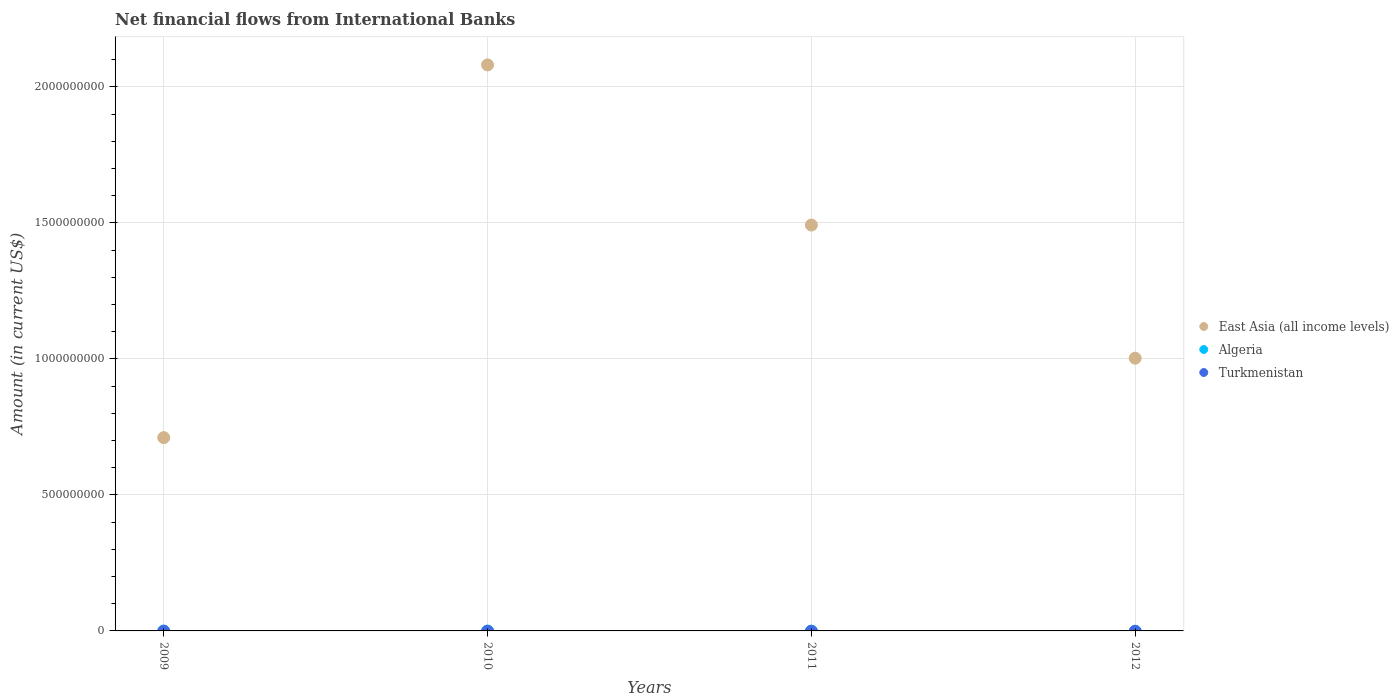What is the net financial aid flows in Turkmenistan in 2012?
Make the answer very short. 0. Across all years, what is the maximum net financial aid flows in East Asia (all income levels)?
Provide a short and direct response. 2.08e+09. Across all years, what is the minimum net financial aid flows in East Asia (all income levels)?
Keep it short and to the point. 7.11e+08. In which year was the net financial aid flows in East Asia (all income levels) maximum?
Provide a short and direct response. 2010. What is the total net financial aid flows in East Asia (all income levels) in the graph?
Your answer should be very brief. 5.29e+09. What is the difference between the net financial aid flows in East Asia (all income levels) in 2009 and that in 2011?
Give a very brief answer. -7.82e+08. What is the difference between the net financial aid flows in East Asia (all income levels) in 2010 and the net financial aid flows in Turkmenistan in 2009?
Provide a succinct answer. 2.08e+09. What is the average net financial aid flows in East Asia (all income levels) per year?
Provide a short and direct response. 1.32e+09. What is the difference between the highest and the second highest net financial aid flows in East Asia (all income levels)?
Your answer should be compact. 5.89e+08. What is the difference between the highest and the lowest net financial aid flows in East Asia (all income levels)?
Provide a succinct answer. 1.37e+09. In how many years, is the net financial aid flows in Algeria greater than the average net financial aid flows in Algeria taken over all years?
Provide a succinct answer. 0. Is the net financial aid flows in Turkmenistan strictly less than the net financial aid flows in East Asia (all income levels) over the years?
Make the answer very short. Yes. How many dotlines are there?
Provide a succinct answer. 1. Does the graph contain any zero values?
Your response must be concise. Yes. What is the title of the graph?
Offer a very short reply. Net financial flows from International Banks. Does "Cambodia" appear as one of the legend labels in the graph?
Your answer should be very brief. No. What is the label or title of the X-axis?
Give a very brief answer. Years. What is the label or title of the Y-axis?
Offer a terse response. Amount (in current US$). What is the Amount (in current US$) of East Asia (all income levels) in 2009?
Keep it short and to the point. 7.11e+08. What is the Amount (in current US$) of East Asia (all income levels) in 2010?
Your answer should be very brief. 2.08e+09. What is the Amount (in current US$) of East Asia (all income levels) in 2011?
Offer a terse response. 1.49e+09. What is the Amount (in current US$) in Turkmenistan in 2011?
Provide a succinct answer. 0. What is the Amount (in current US$) of East Asia (all income levels) in 2012?
Keep it short and to the point. 1.00e+09. Across all years, what is the maximum Amount (in current US$) of East Asia (all income levels)?
Your answer should be compact. 2.08e+09. Across all years, what is the minimum Amount (in current US$) in East Asia (all income levels)?
Ensure brevity in your answer.  7.11e+08. What is the total Amount (in current US$) of East Asia (all income levels) in the graph?
Offer a terse response. 5.29e+09. What is the total Amount (in current US$) of Algeria in the graph?
Offer a terse response. 0. What is the difference between the Amount (in current US$) in East Asia (all income levels) in 2009 and that in 2010?
Offer a terse response. -1.37e+09. What is the difference between the Amount (in current US$) in East Asia (all income levels) in 2009 and that in 2011?
Offer a very short reply. -7.82e+08. What is the difference between the Amount (in current US$) in East Asia (all income levels) in 2009 and that in 2012?
Give a very brief answer. -2.92e+08. What is the difference between the Amount (in current US$) of East Asia (all income levels) in 2010 and that in 2011?
Your answer should be very brief. 5.89e+08. What is the difference between the Amount (in current US$) in East Asia (all income levels) in 2010 and that in 2012?
Make the answer very short. 1.08e+09. What is the difference between the Amount (in current US$) in East Asia (all income levels) in 2011 and that in 2012?
Offer a very short reply. 4.90e+08. What is the average Amount (in current US$) of East Asia (all income levels) per year?
Keep it short and to the point. 1.32e+09. What is the average Amount (in current US$) of Algeria per year?
Make the answer very short. 0. What is the average Amount (in current US$) in Turkmenistan per year?
Offer a very short reply. 0. What is the ratio of the Amount (in current US$) in East Asia (all income levels) in 2009 to that in 2010?
Provide a short and direct response. 0.34. What is the ratio of the Amount (in current US$) in East Asia (all income levels) in 2009 to that in 2011?
Ensure brevity in your answer.  0.48. What is the ratio of the Amount (in current US$) of East Asia (all income levels) in 2009 to that in 2012?
Provide a short and direct response. 0.71. What is the ratio of the Amount (in current US$) of East Asia (all income levels) in 2010 to that in 2011?
Your response must be concise. 1.39. What is the ratio of the Amount (in current US$) in East Asia (all income levels) in 2010 to that in 2012?
Your answer should be compact. 2.08. What is the ratio of the Amount (in current US$) in East Asia (all income levels) in 2011 to that in 2012?
Your response must be concise. 1.49. What is the difference between the highest and the second highest Amount (in current US$) of East Asia (all income levels)?
Your answer should be compact. 5.89e+08. What is the difference between the highest and the lowest Amount (in current US$) of East Asia (all income levels)?
Your answer should be very brief. 1.37e+09. 